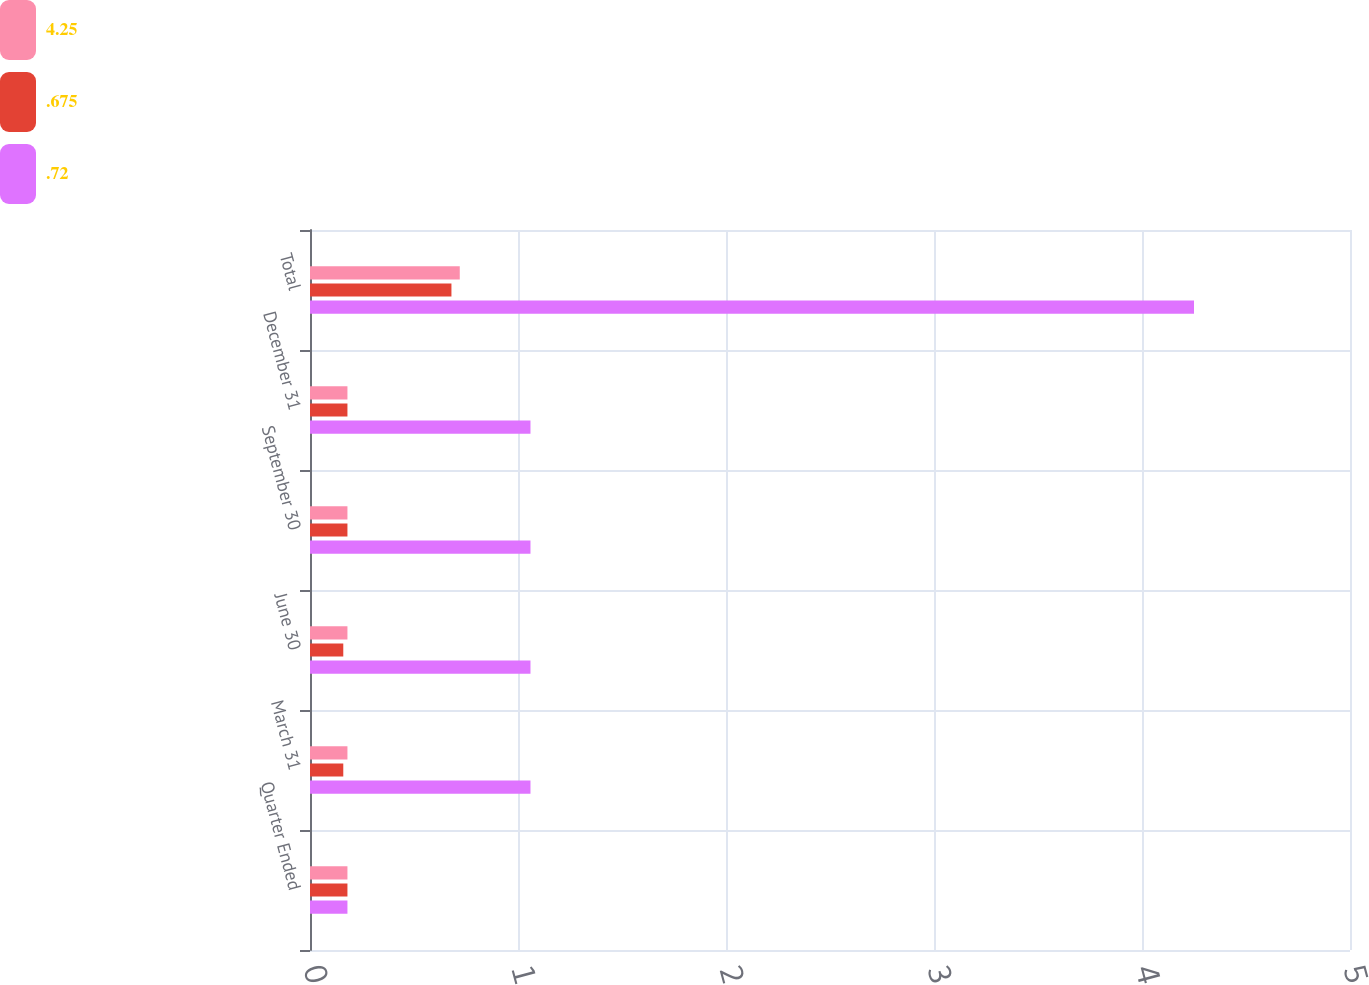<chart> <loc_0><loc_0><loc_500><loc_500><stacked_bar_chart><ecel><fcel>Quarter Ended<fcel>March 31<fcel>June 30<fcel>September 30<fcel>December 31<fcel>Total<nl><fcel>4.25<fcel>0.18<fcel>0.18<fcel>0.18<fcel>0.18<fcel>0.18<fcel>0.72<nl><fcel>0.675<fcel>0.18<fcel>0.16<fcel>0.16<fcel>0.18<fcel>0.18<fcel>0.68<nl><fcel>0.72<fcel>0.18<fcel>1.06<fcel>1.06<fcel>1.06<fcel>1.06<fcel>4.25<nl></chart> 